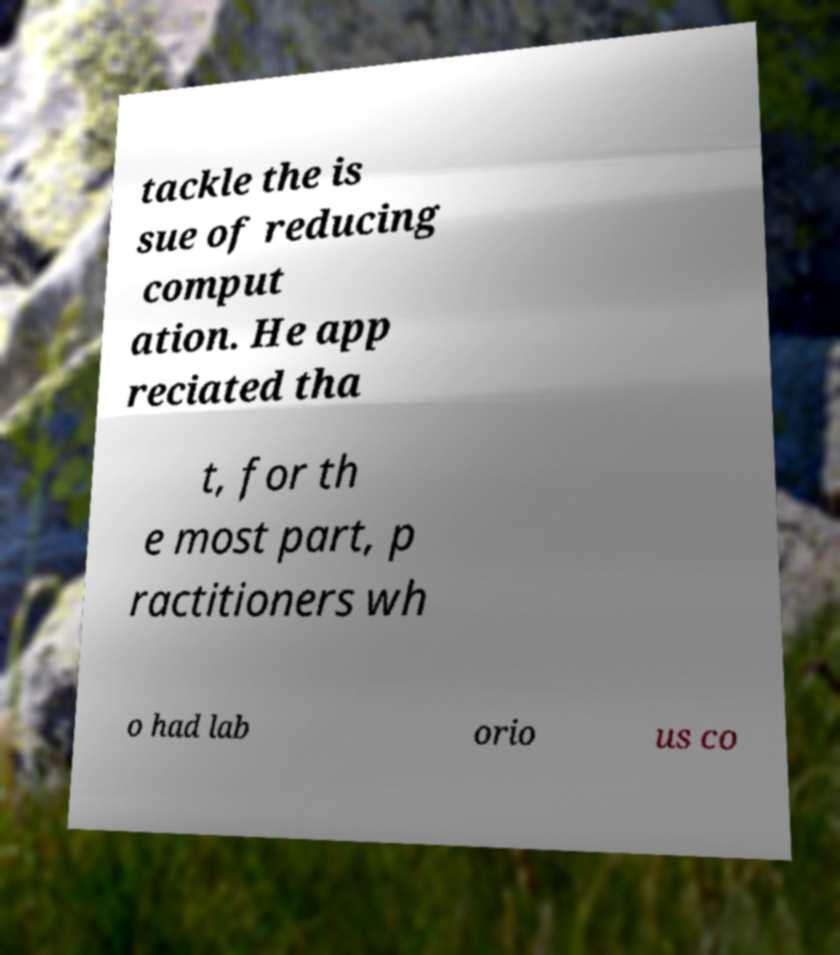I need the written content from this picture converted into text. Can you do that? tackle the is sue of reducing comput ation. He app reciated tha t, for th e most part, p ractitioners wh o had lab orio us co 